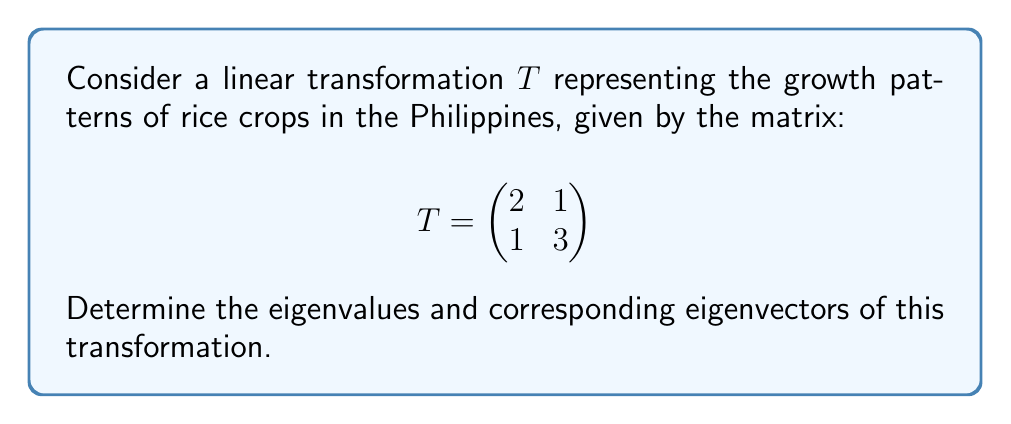Could you help me with this problem? To find the eigenvalues and eigenvectors, we follow these steps:

1) Find the characteristic equation:
   $det(T - \lambda I) = 0$
   
   $$\begin{vmatrix}
   2-\lambda & 1 \\
   1 & 3-\lambda
   \end{vmatrix} = 0$$

2) Expand the determinant:
   $(2-\lambda)(3-\lambda) - 1 = 0$
   $\lambda^2 - 5\lambda + 5 = 0$

3) Solve the quadratic equation:
   Using the quadratic formula, $\lambda = \frac{-b \pm \sqrt{b^2 - 4ac}}{2a}$
   
   $\lambda = \frac{5 \pm \sqrt{25 - 20}}{2} = \frac{5 \pm \sqrt{5}}{2}$

4) The eigenvalues are:
   $\lambda_1 = \frac{5 + \sqrt{5}}{2}$ and $\lambda_2 = \frac{5 - \sqrt{5}}{2}$

5) For each eigenvalue, find the eigenvectors:
   For $\lambda_1$:
   $$(T - \lambda_1 I)v = 0$$
   $$\begin{pmatrix}
   2-\frac{5+\sqrt{5}}{2} & 1 \\
   1 & 3-\frac{5+\sqrt{5}}{2}
   \end{pmatrix}\begin{pmatrix}
   v_1 \\
   v_2
   \end{pmatrix} = \begin{pmatrix}
   0 \\
   0
   \end{pmatrix}$$

   Solving this system gives us:
   $v_1 = 1$, $v_2 = \frac{\sqrt{5}-1}{2}$

   For $\lambda_2$:
   $$(T - \lambda_2 I)v = 0$$
   $$\begin{pmatrix}
   2-\frac{5-\sqrt{5}}{2} & 1 \\
   1 & 3-\frac{5-\sqrt{5}}{2}
   \end{pmatrix}\begin{pmatrix}
   v_1 \\
   v_2
   \end{pmatrix} = \begin{pmatrix}
   0 \\
   0
   \end{pmatrix}$$

   Solving this system gives us:
   $v_1 = 1$, $v_2 = -\frac{\sqrt{5}+1}{2}$
Answer: Eigenvalues: $\lambda_1 = \frac{5 + \sqrt{5}}{2}$, $\lambda_2 = \frac{5 - \sqrt{5}}{2}$
Eigenvectors: $v_1 = \begin{pmatrix} 1 \\ \frac{\sqrt{5}-1}{2} \end{pmatrix}$, $v_2 = \begin{pmatrix} 1 \\ -\frac{\sqrt{5}+1}{2} \end{pmatrix}$ 